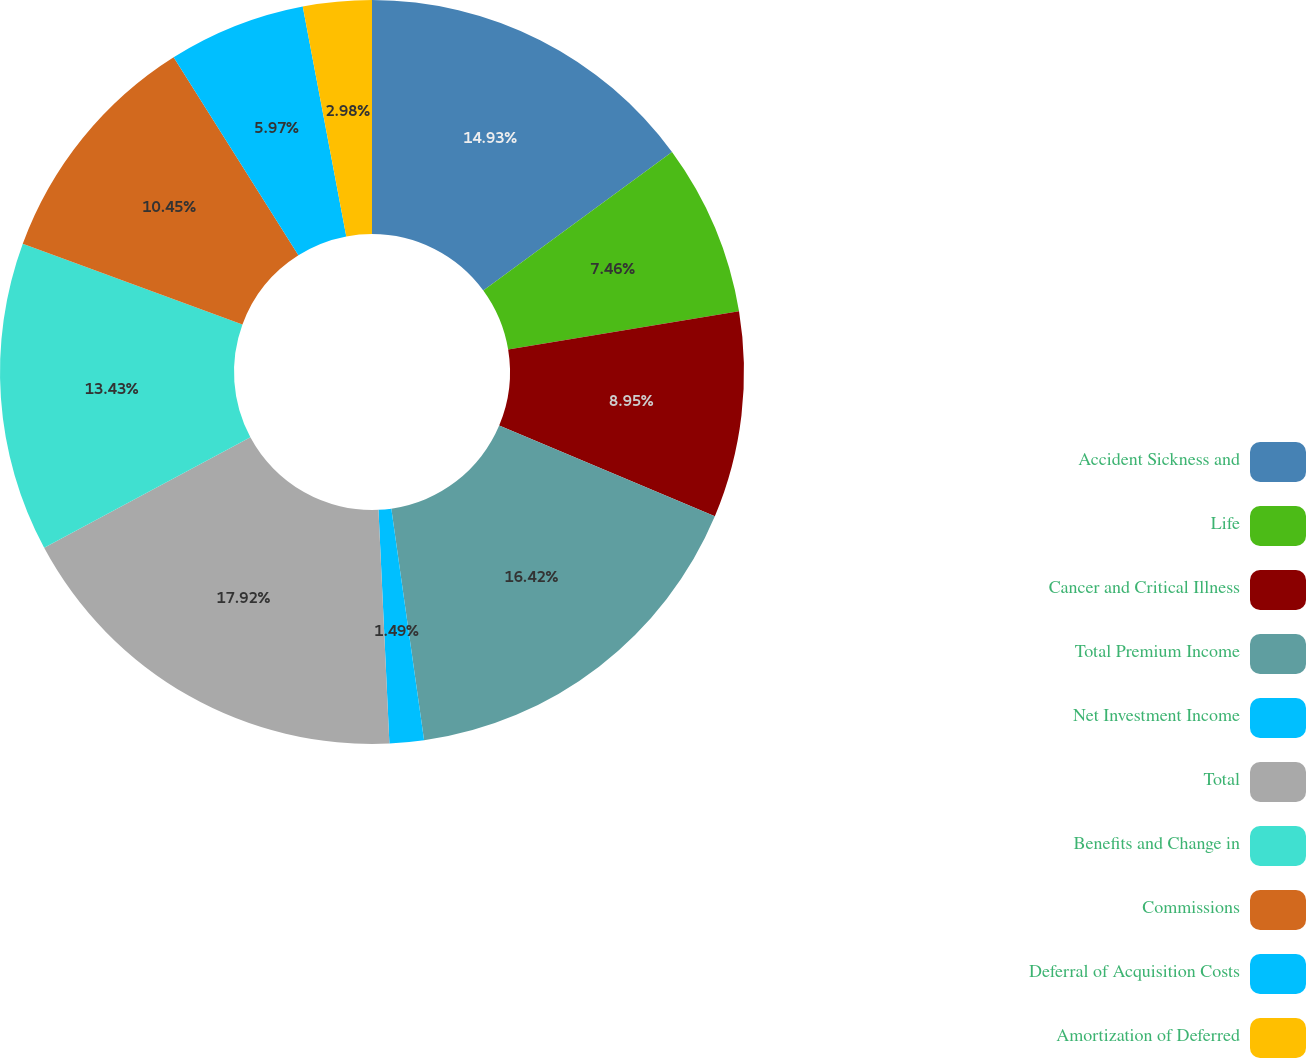Convert chart. <chart><loc_0><loc_0><loc_500><loc_500><pie_chart><fcel>Accident Sickness and<fcel>Life<fcel>Cancer and Critical Illness<fcel>Total Premium Income<fcel>Net Investment Income<fcel>Total<fcel>Benefits and Change in<fcel>Commissions<fcel>Deferral of Acquisition Costs<fcel>Amortization of Deferred<nl><fcel>14.93%<fcel>7.46%<fcel>8.95%<fcel>16.42%<fcel>1.49%<fcel>17.91%<fcel>13.43%<fcel>10.45%<fcel>5.97%<fcel>2.98%<nl></chart> 